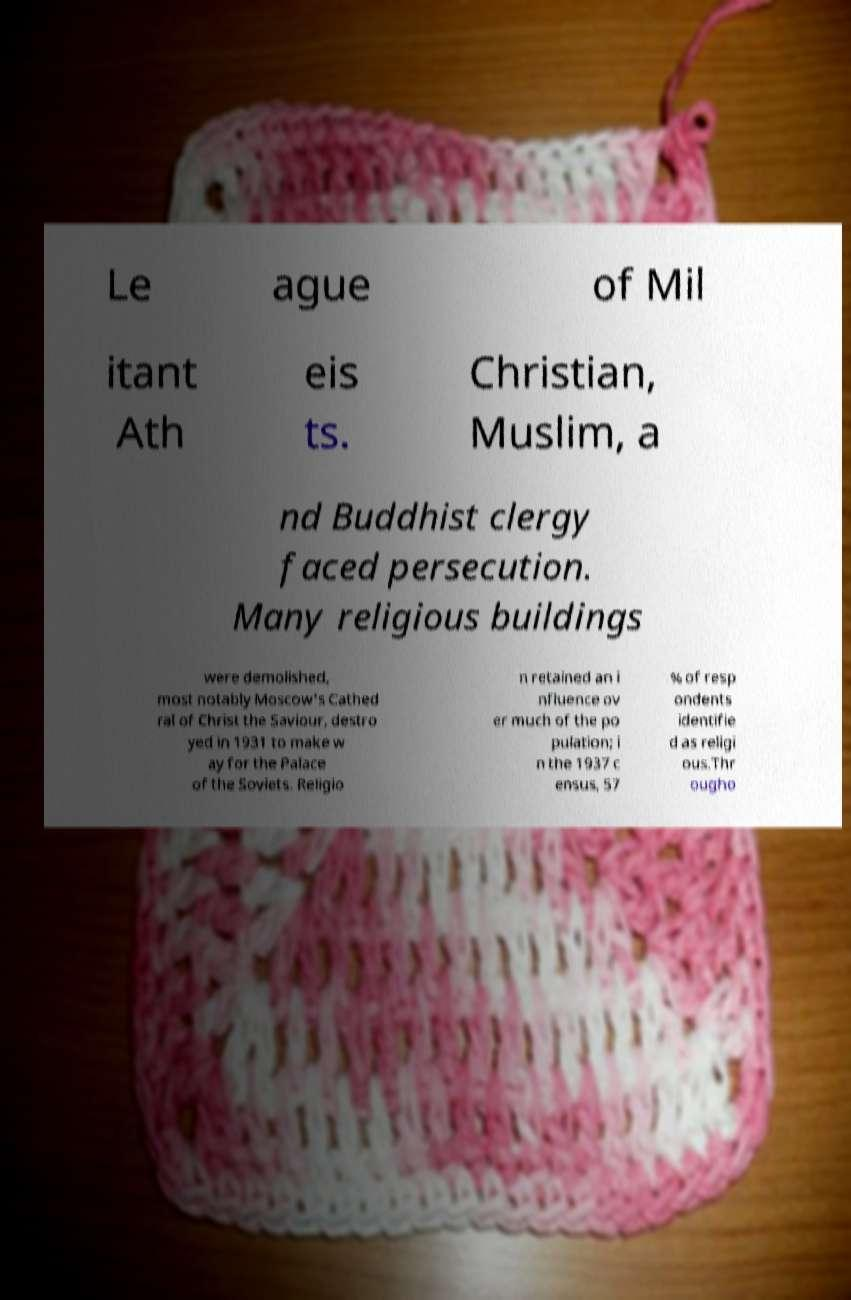Can you accurately transcribe the text from the provided image for me? Le ague of Mil itant Ath eis ts. Christian, Muslim, a nd Buddhist clergy faced persecution. Many religious buildings were demolished, most notably Moscow's Cathed ral of Christ the Saviour, destro yed in 1931 to make w ay for the Palace of the Soviets. Religio n retained an i nfluence ov er much of the po pulation; i n the 1937 c ensus, 57 % of resp ondents identifie d as religi ous.Thr ougho 